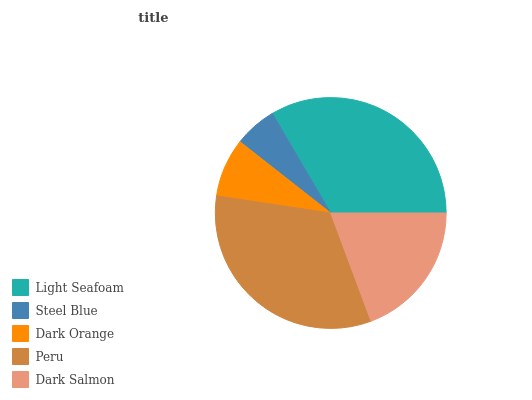Is Steel Blue the minimum?
Answer yes or no. Yes. Is Light Seafoam the maximum?
Answer yes or no. Yes. Is Dark Orange the minimum?
Answer yes or no. No. Is Dark Orange the maximum?
Answer yes or no. No. Is Dark Orange greater than Steel Blue?
Answer yes or no. Yes. Is Steel Blue less than Dark Orange?
Answer yes or no. Yes. Is Steel Blue greater than Dark Orange?
Answer yes or no. No. Is Dark Orange less than Steel Blue?
Answer yes or no. No. Is Dark Salmon the high median?
Answer yes or no. Yes. Is Dark Salmon the low median?
Answer yes or no. Yes. Is Light Seafoam the high median?
Answer yes or no. No. Is Dark Orange the low median?
Answer yes or no. No. 